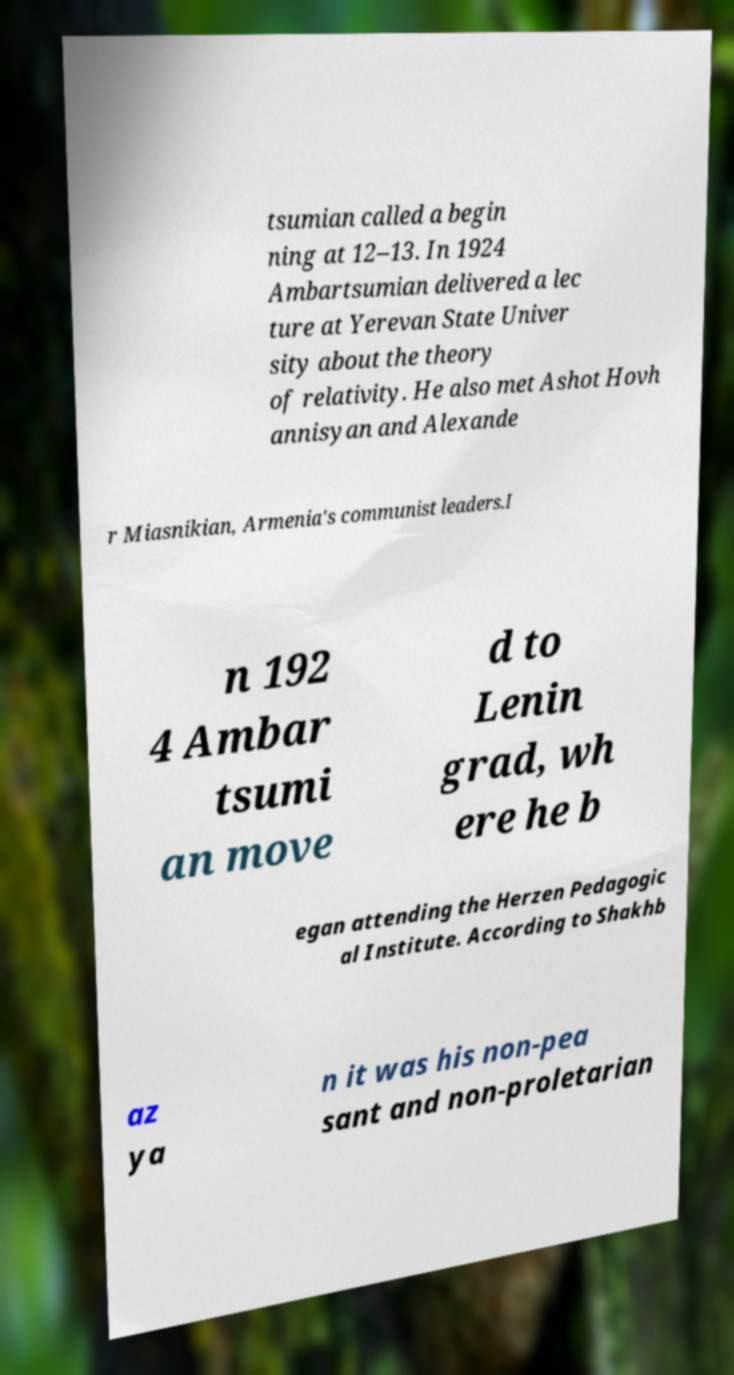What messages or text are displayed in this image? I need them in a readable, typed format. tsumian called a begin ning at 12–13. In 1924 Ambartsumian delivered a lec ture at Yerevan State Univer sity about the theory of relativity. He also met Ashot Hovh annisyan and Alexande r Miasnikian, Armenia's communist leaders.I n 192 4 Ambar tsumi an move d to Lenin grad, wh ere he b egan attending the Herzen Pedagogic al Institute. According to Shakhb az ya n it was his non-pea sant and non-proletarian 